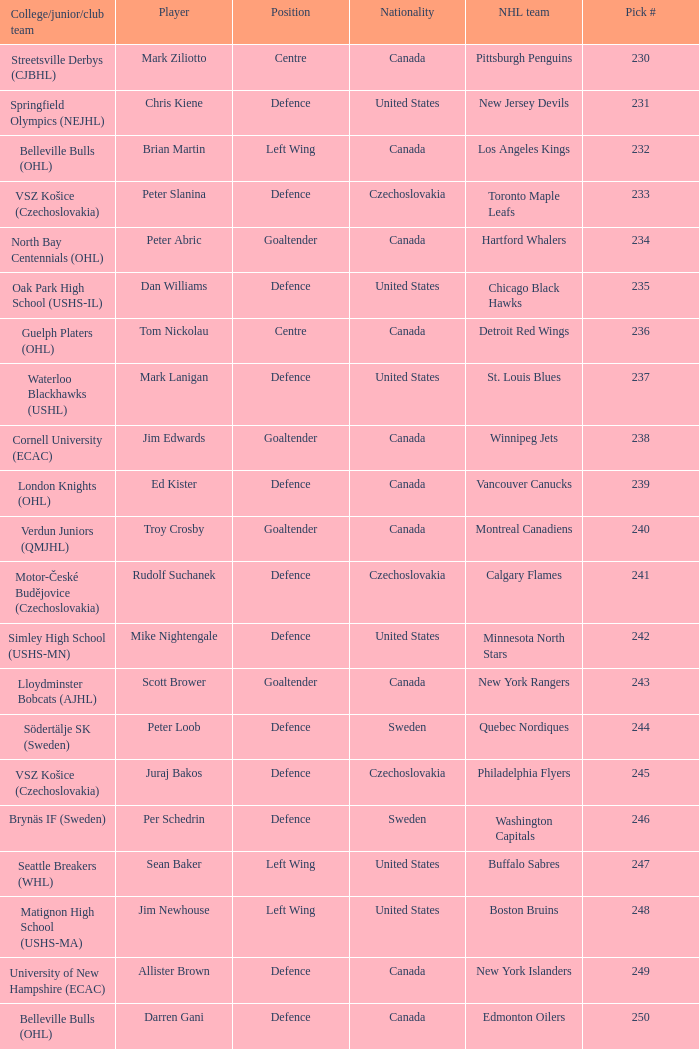What position does allister brown play. Defence. 